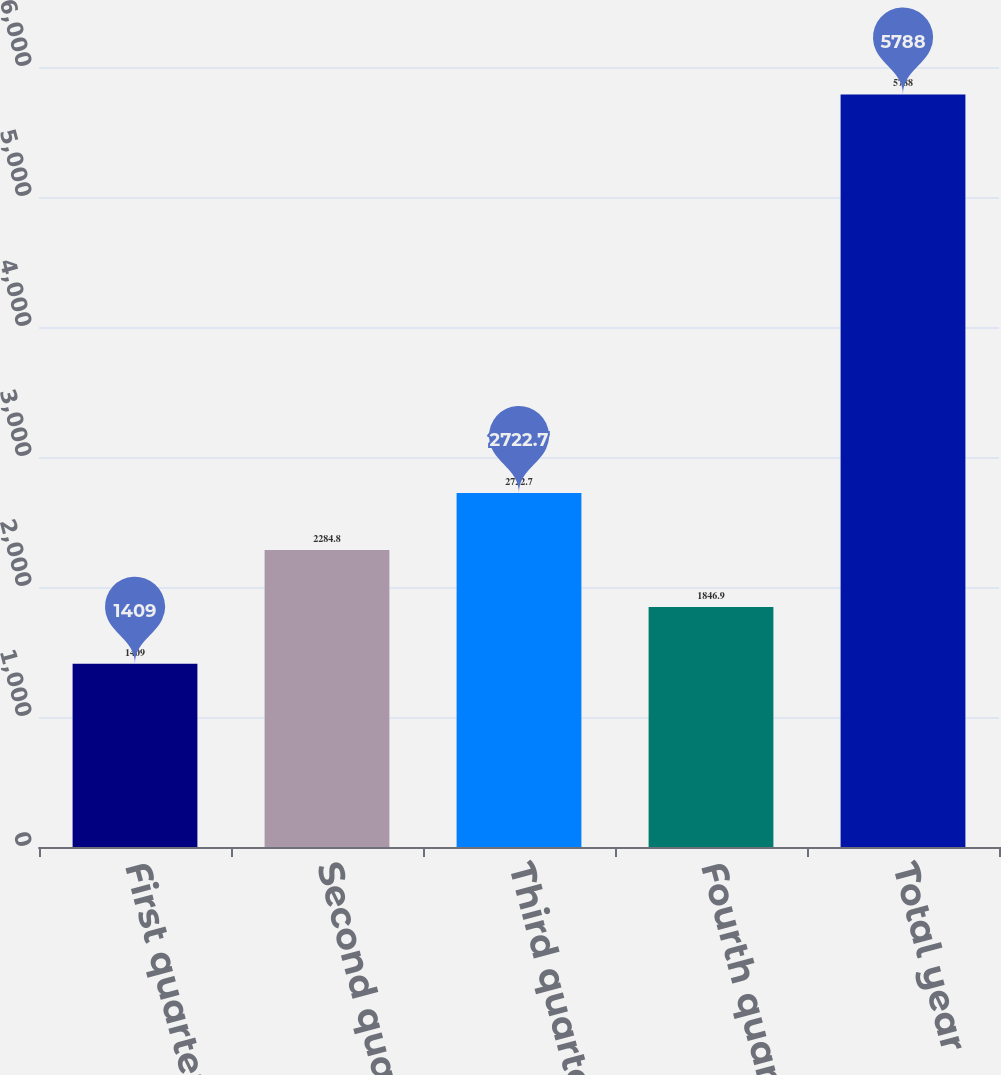<chart> <loc_0><loc_0><loc_500><loc_500><bar_chart><fcel>First quarter<fcel>Second quarter<fcel>Third quarter<fcel>Fourth quarter<fcel>Total year<nl><fcel>1409<fcel>2284.8<fcel>2722.7<fcel>1846.9<fcel>5788<nl></chart> 